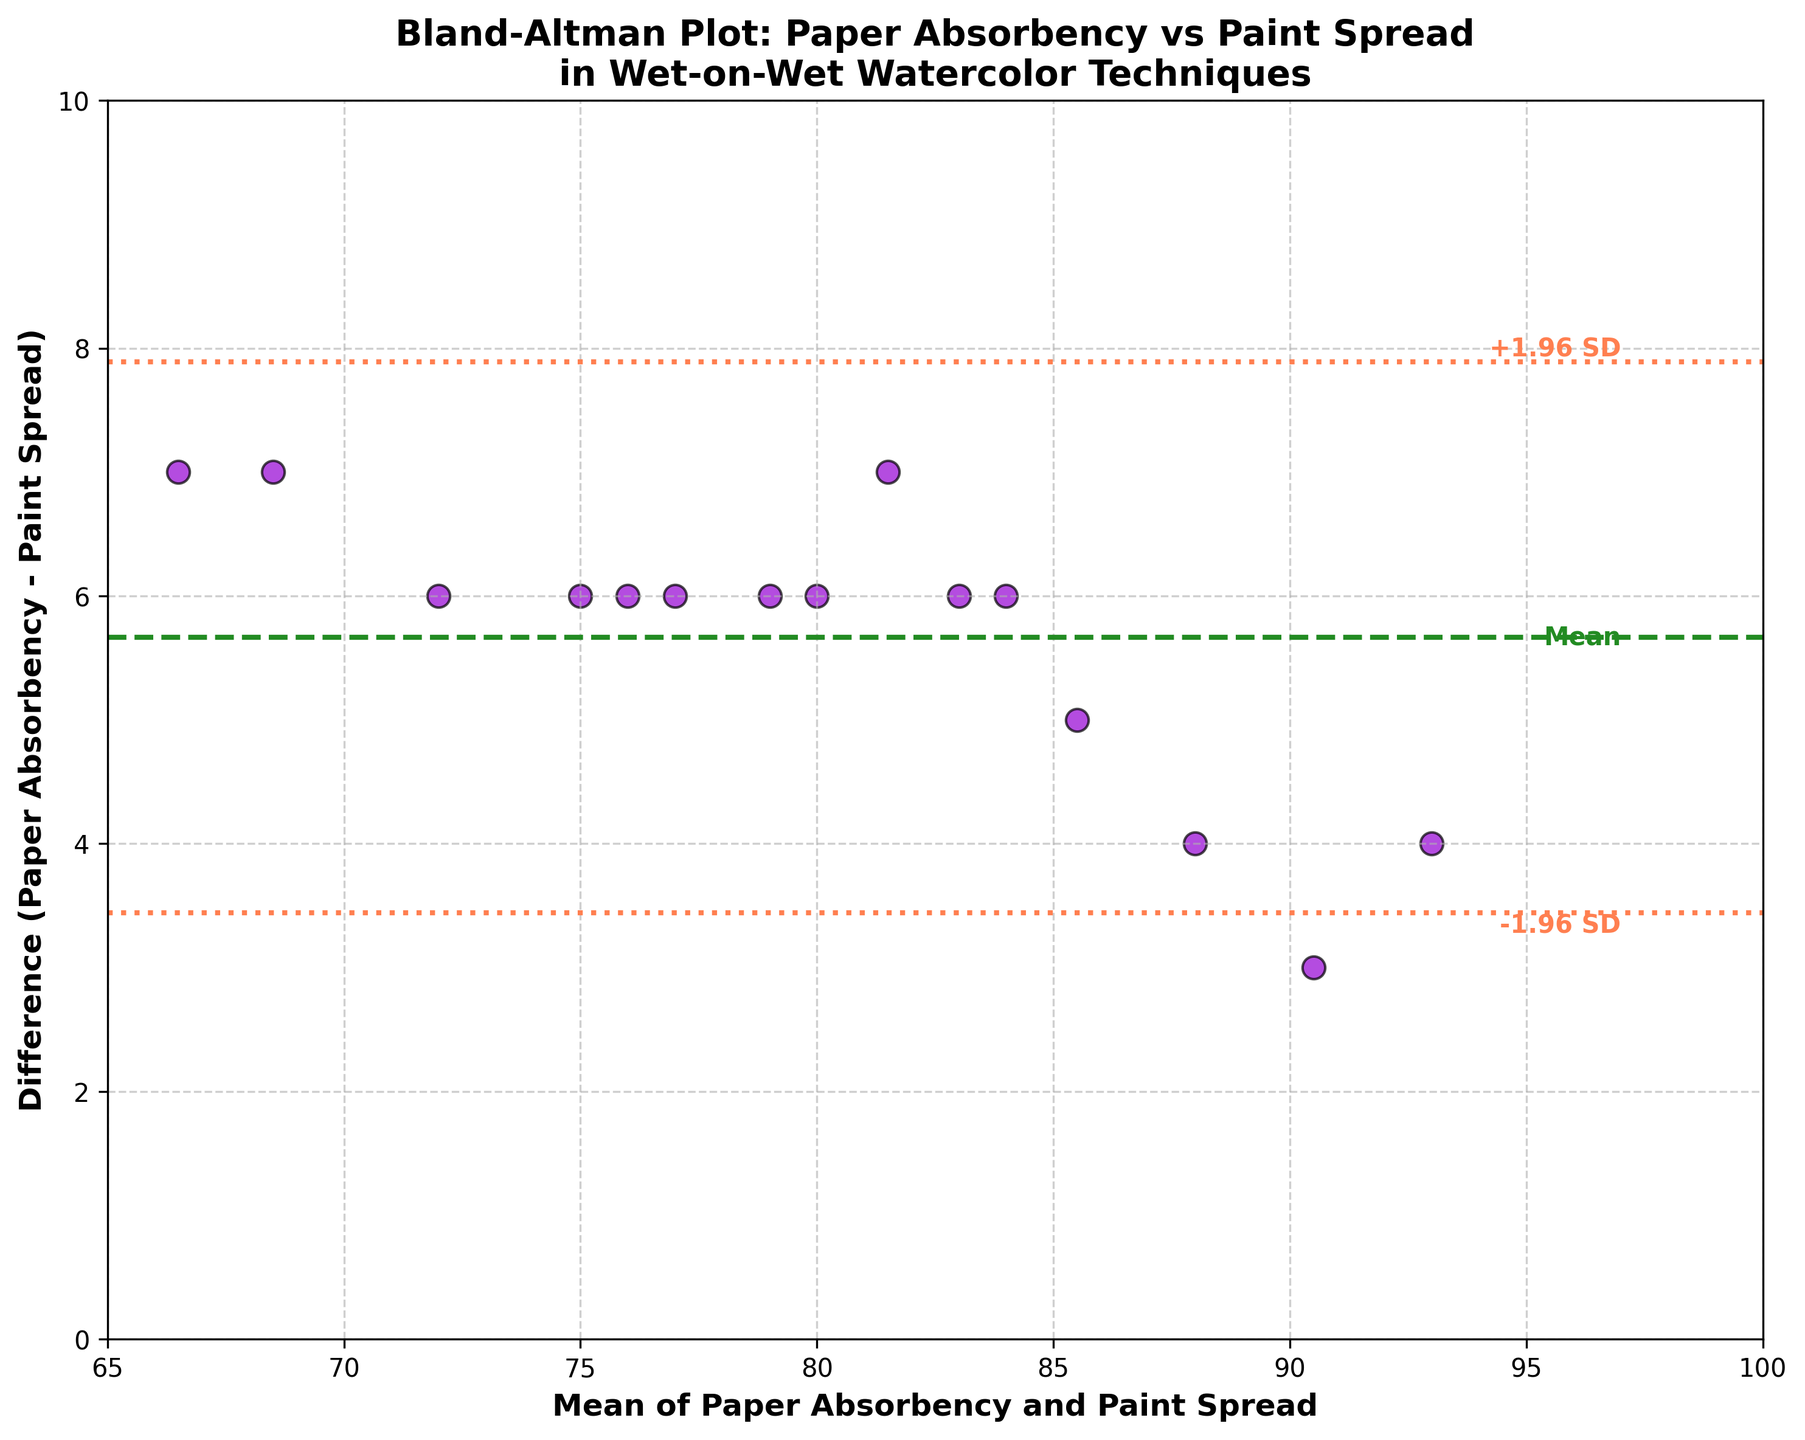what does the title of the figure say? The title is written at the top of the figure in bold letters, indicating what the plot represents.
Answer: Bland-Altman Plot: Paper Absorbency vs Paint Spread in Wet-on-Wet Watercolor Techniques what is represented on the y-axis? The label on the y-axis usually tells us what data is plotted, which in this case is specified in bold letters.
Answer: Difference (Paper Absorbency - Paint Spread) what are the mean and difference values for 'Stonehenge Aqua'? Identify the 'Stonehenge Aqua' point from the data, then calculate the mean of Paper Absorbency (83) and Paint Spread (77), and their difference.
Answer: Mean = 80, Difference = 6 how many data points are plotted? Count the total number of data points that are scattered on the plot; corresponding the number of filled circles.
Answer: 15 what are the color codes used for the horizontal lines? The lines are visually distinguished by their colors, which are described by their natural names in the question.
Answer: Mean line is forestgreen, ±1.96 SD lines are coral what is the standard deviation of the differences? Derive the standard deviation by analyzing the distance between the mean line and the ±1.96 SD lines, then dividing by 1.96.
Answer: 4.05 which paper has the largest difference between paper absorbency and paint spread? Identify the maximum difference by examining the scatter points' vertical distances from the mean line. The paper name corresponding to this highest point is the answer.
Answer: Khadi Handmade what is the average of the means of paper absorbency and paint spread? Calculate the mean for each pair, sum them up, and then divide by the number of data points. Sum = (85+78+...+72+65)/15 = 1234; Average = 1234/15
Answer: 82.27 is the relationship between paper absorbency and paint spread generally consistent across papers? Assess the scattering of points and whether most differences are close to the mean difference line.
Answer: Yes, mostly within ±1.96 SD 